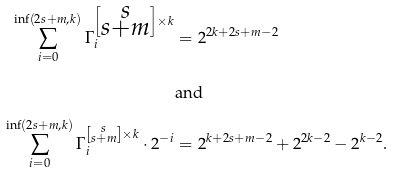Convert formula to latex. <formula><loc_0><loc_0><loc_500><loc_500>\sum _ { i = 0 } ^ { \inf ( 2 s + m , k ) } \Gamma _ { i } ^ { \left [ \substack { s \\ s + m } \right ] \times k } & = 2 ^ { 2 k + 2 s + m - 2 } \\ & \text {and} \\ \sum _ { i = 0 } ^ { \inf ( 2 s + m , k ) } \Gamma _ { i } ^ { \left [ \substack { s \\ s + m } \right ] \times k } \cdot 2 ^ { - i } & = 2 ^ { k + 2 s + m - 2 } + 2 ^ { 2 k - 2 } - 2 ^ { k - 2 } .</formula> 